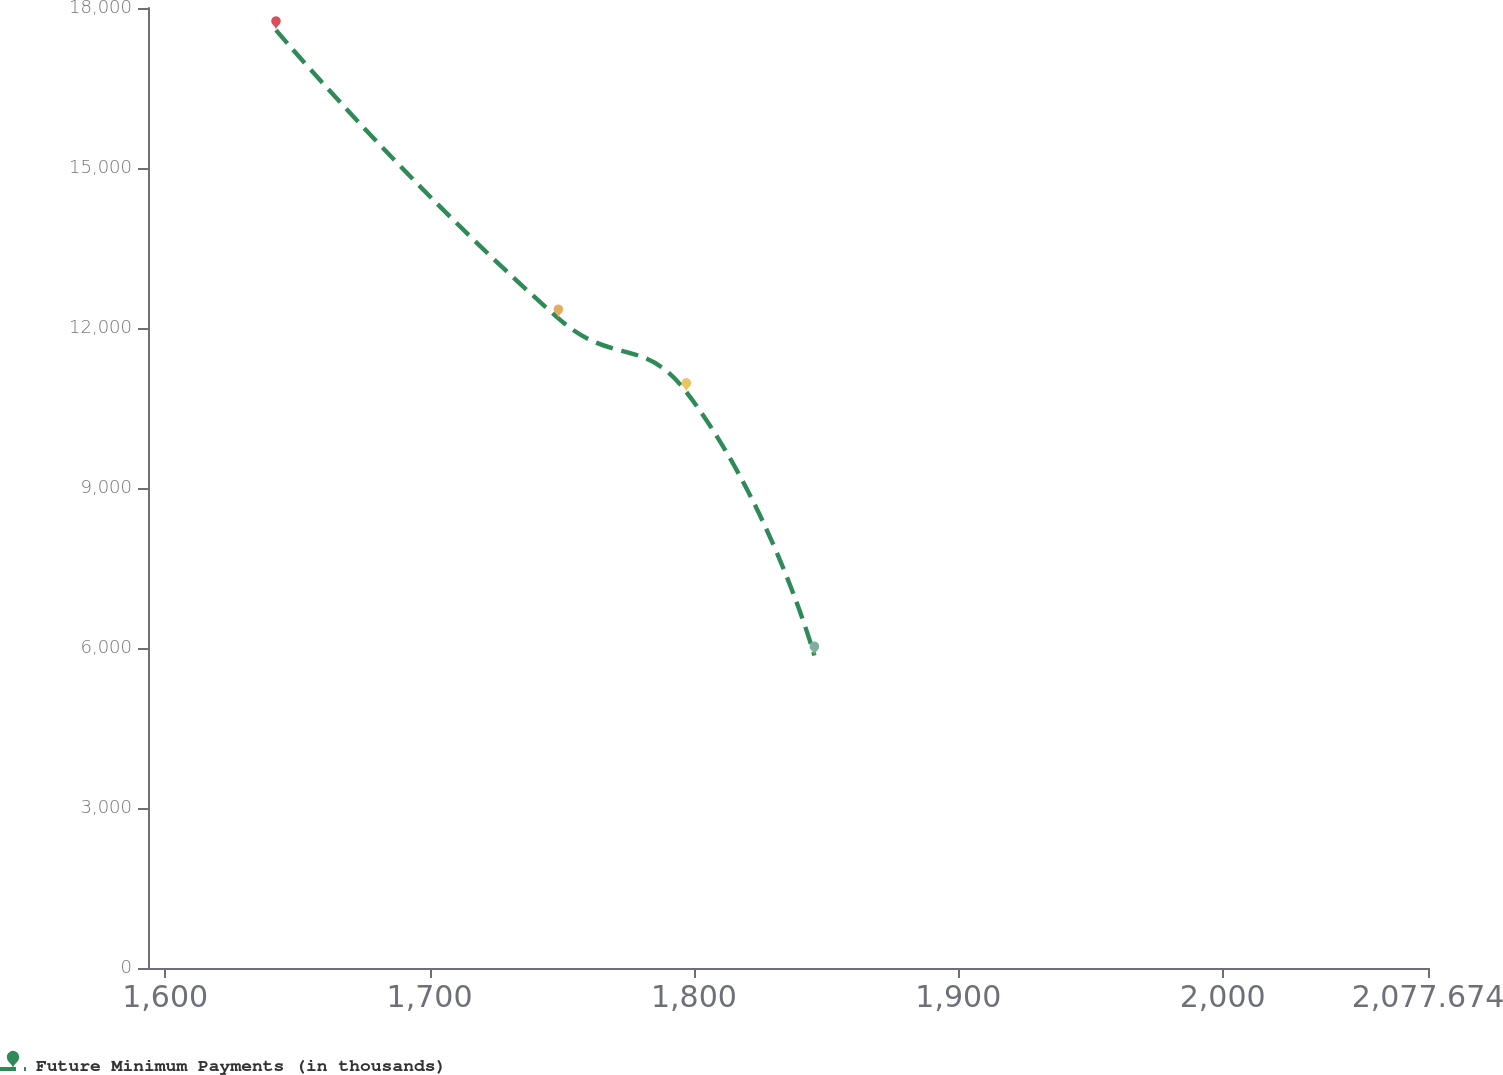Convert chart to OTSL. <chart><loc_0><loc_0><loc_500><loc_500><line_chart><ecel><fcel>Future Minimum Payments (in thousands)<nl><fcel>1641.93<fcel>17584.2<nl><fcel>1748.75<fcel>12180.6<nl><fcel>1797.17<fcel>10799<nl><fcel>1845.59<fcel>5859.15<nl><fcel>2126.09<fcel>3768.98<nl></chart> 